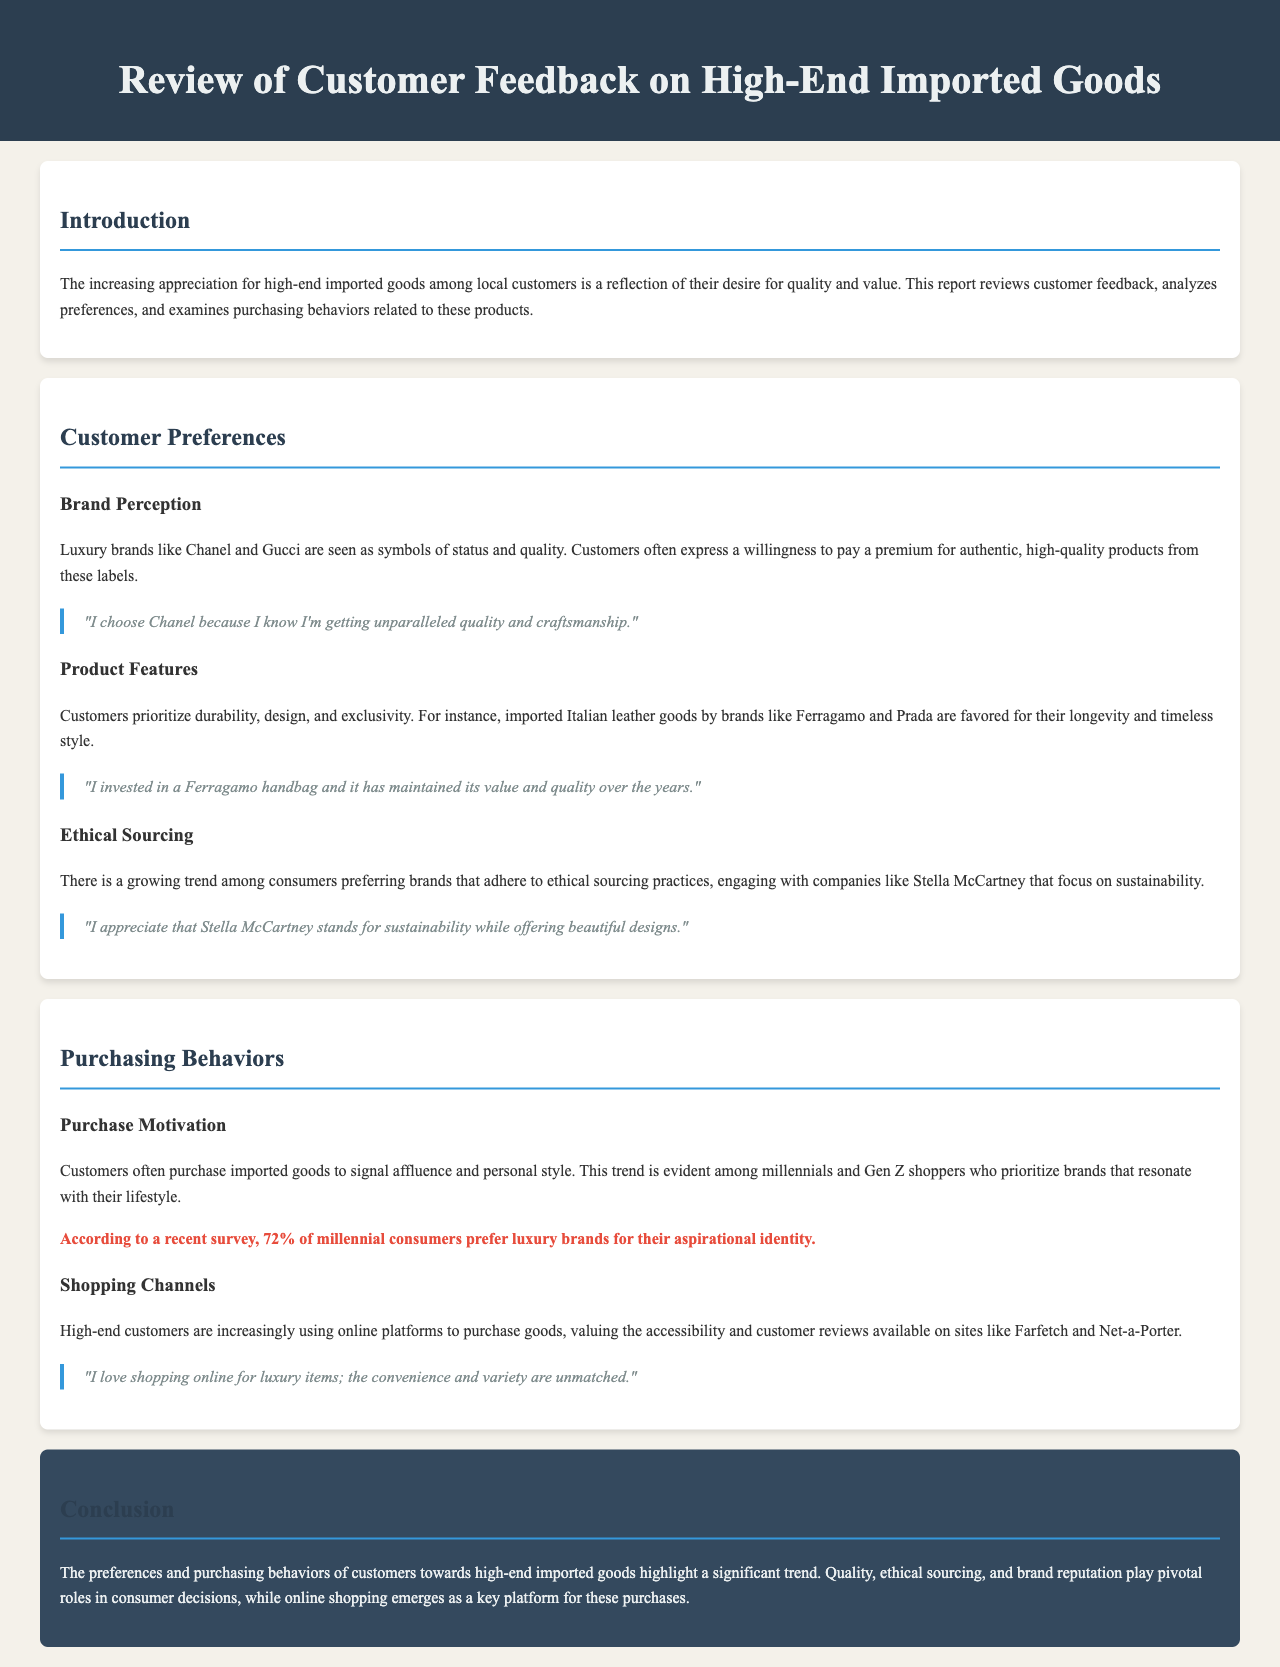What is the main subject of the report? The report focuses on customer feedback regarding high-end imported goods, analyzing preferences and purchasing behaviors.
Answer: Customer feedback on high-end imported goods Which luxury brands are mentioned in the document? Brands like Chanel and Gucci are specifically cited as symbols of status and quality.
Answer: Chanel and Gucci What percentage of millennial consumers prefer luxury brands? A statistic from a recent survey indicates that 72% of millennial consumers prefer luxury brands.
Answer: 72% What aspect of products do customers prioritize according to the report? Customers prioritize durability, design, and exclusivity when selecting products.
Answer: Durability, design, and exclusivity Which brand is noted for its focus on sustainability? Stella McCartney is highlighted for its commitment to sustainability and ethical sourcing practices.
Answer: Stella McCartney What shopping trend is observed among high-end customers? High-end customers are increasingly using online platforms for their purchases.
Answer: Online platforms Which demographic is indicated as showing a trend towards luxury brand preferences? Millennials and Gen Z shoppers are specifically mentioned as prioritizing brands that resonate with their lifestyle.
Answer: Millennials and Gen Z What is a key factor influencing consumer decisions on high-end imported goods? Quality, ethical sourcing, and brand reputation are pivotal factors in consumer decisions.
Answer: Quality, ethical sourcing, and brand reputation 